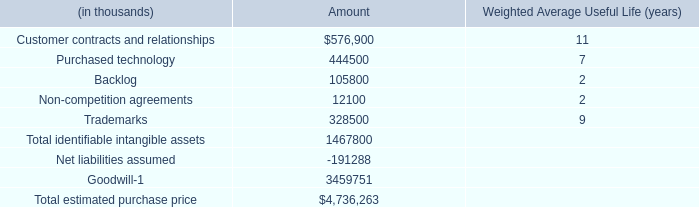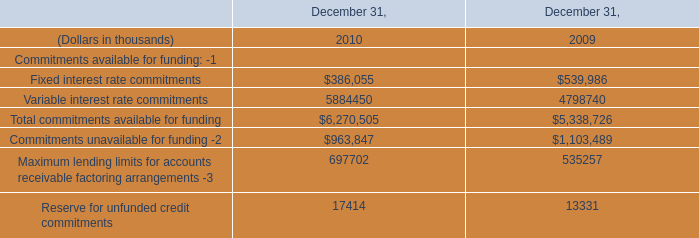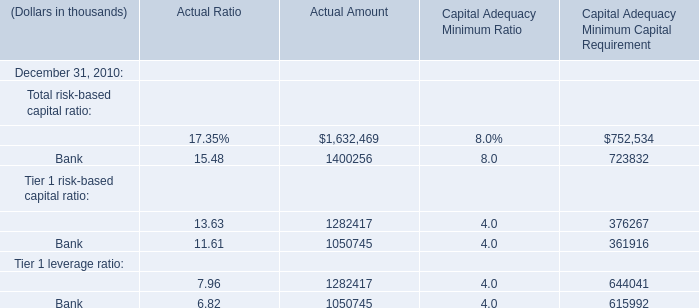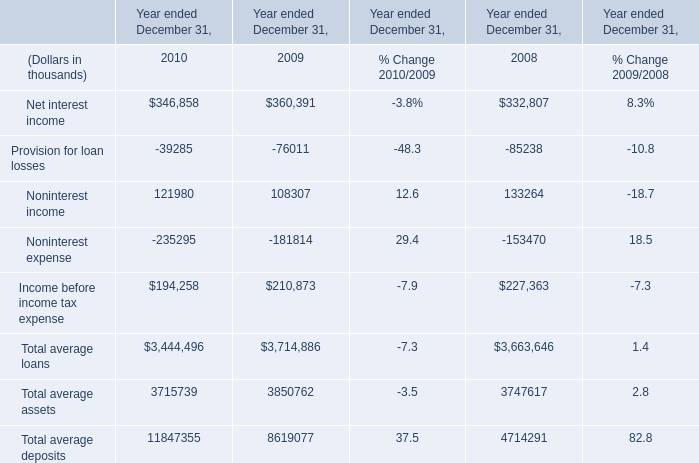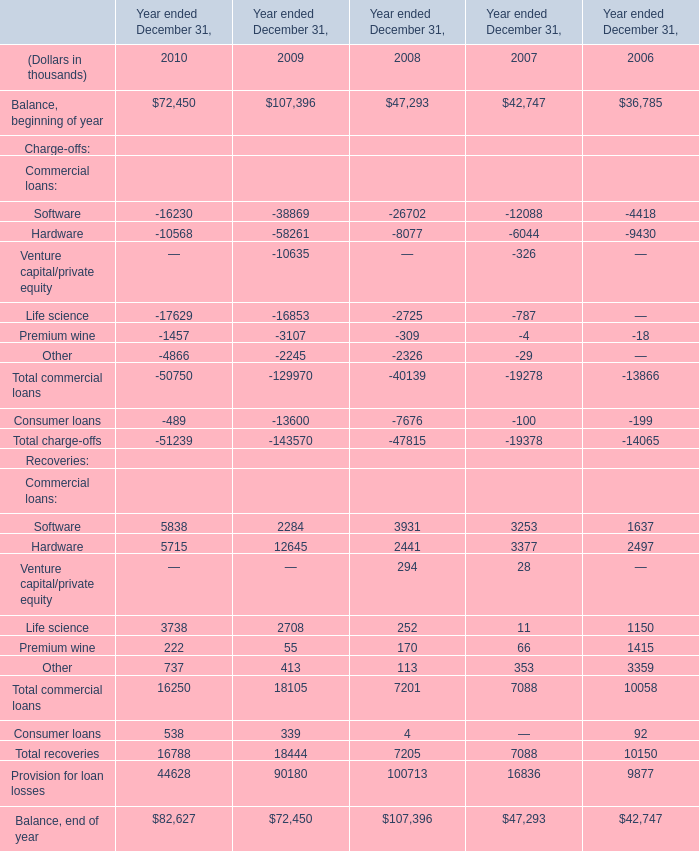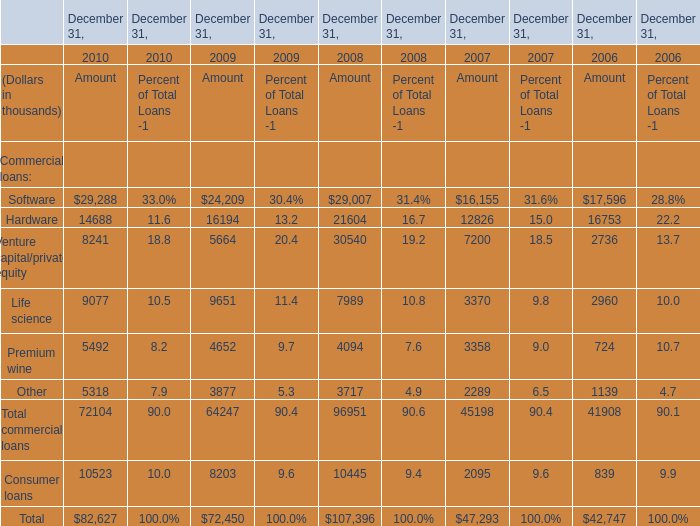What's the current increasing rate of Balance, beginning of year? 
Computations: ((72450 - 107396) / 107396)
Answer: -0.32539. 